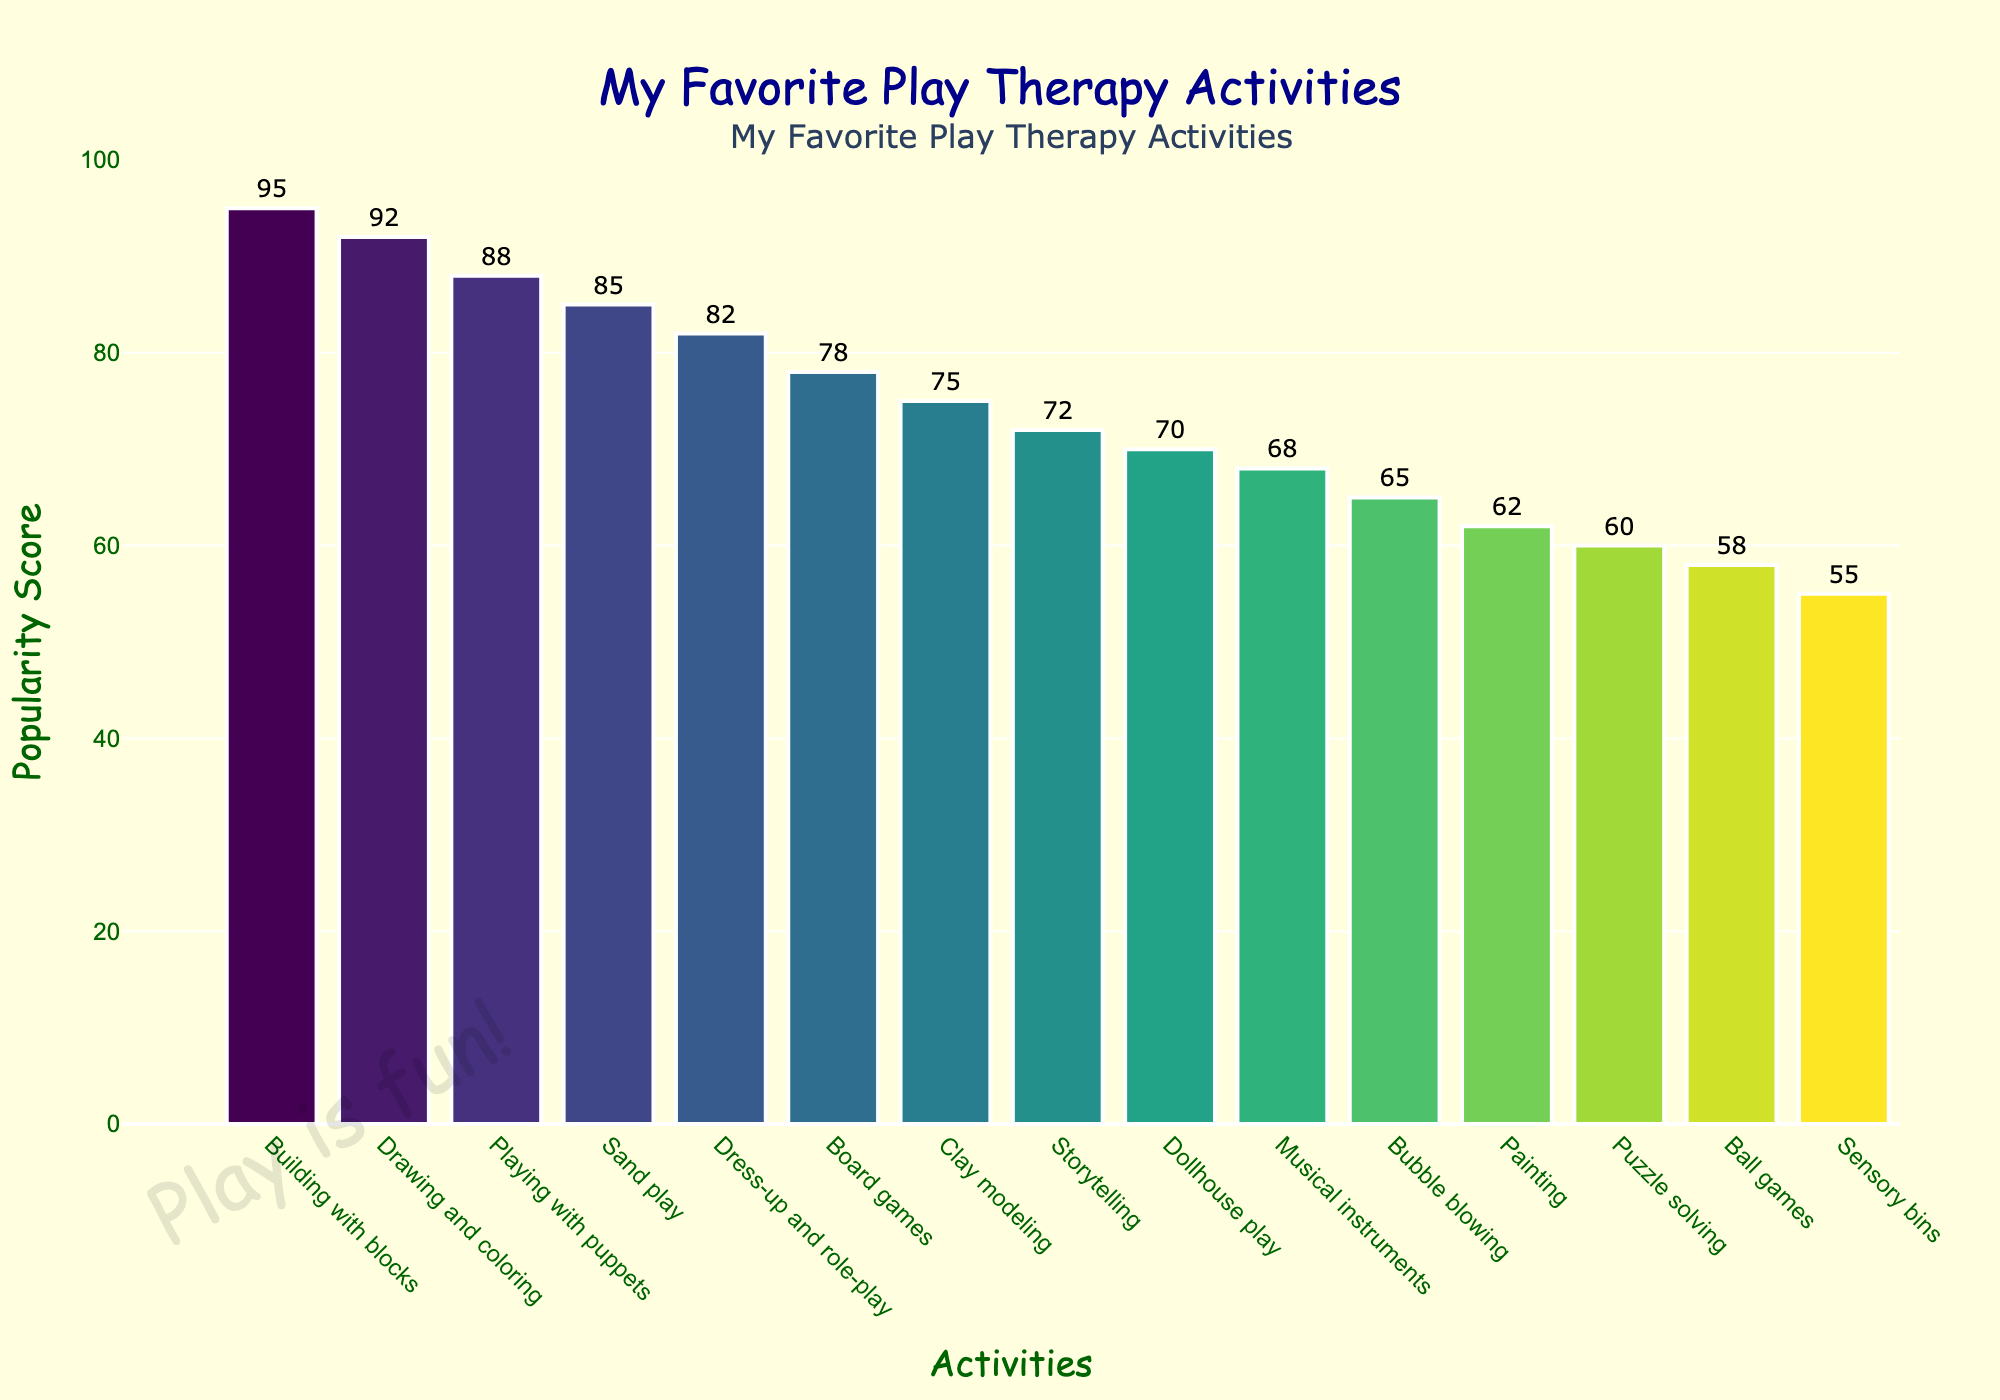Which play therapy activity is the most popular? The activity with the highest bar represents the most popular activity. From the chart, "Building with blocks" has the highest popularity score.
Answer: Building with blocks What is the total popularity score of the top three activities combined? The top three activities are "Building with blocks" (95), "Drawing and coloring" (92), and "Playing with puppets" (88). Adding these scores gives 95 + 92 + 88 = 275.
Answer: 275 Which activity has a higher popularity score: "Dress-up and role-play" or "Board games"? By comparing the heights of the bars, "Dress-up and role-play" has a popularity score of 82, while "Board games" has a popularity score of 78.
Answer: Dress-up and role-play How much more popular is "Clay modeling" compared to "Puzzle solving"? "Clay modeling" has a score of 75 and "Puzzle solving" has a score of 60. The difference is 75 - 60 = 15.
Answer: 15 What is the median popularity score of all the activities? There are 15 activities, so the median is the 8th value when ordered from highest to lowest. The ordered scores are [95, 92, 88, 85, 82, 78, 75, 72, 70, 68, 65, 62, 60, 58, 55]. The 8th score is 72.
Answer: 72 Which activity is the least popular? The activity with the lowest bar represents the least popular activity. From the chart, "Sensory bins" has the lowest popularity score.
Answer: Sensory bins What is the average popularity score of activities involving creativity (Drawing and coloring, Painting, Clay modeling)? The scores for creative activities are "Drawing and coloring" (92), "Painting" (62), and "Clay modeling" (75). The sum is 92 + 62 + 75 = 229. There are 3 activities, so the average is 229 / 3 ≈ 76.33.
Answer: 76.33 Which activity has a lower popularity score: "Storytelling" or "Ball games"? By comparing the heights of the bars, "Storytelling" has a popularity score of 72, while "Ball games" has a popularity score of 58.
Answer: Ball games What is the difference in popularity between "Musical instruments" and "Bubble blowing"? "Musical instruments" has a score of 68 and "Bubble blowing" has a score of 65. The difference is 68 - 65 = 3.
Answer: 3 How many activities have a popularity score higher than 80? Counting the bars that exceed the 80-mark, there are 5 activities: "Building with blocks", "Drawing and coloring", "Playing with puppets", "Sand play", "Dress-up and role-play".
Answer: 5 